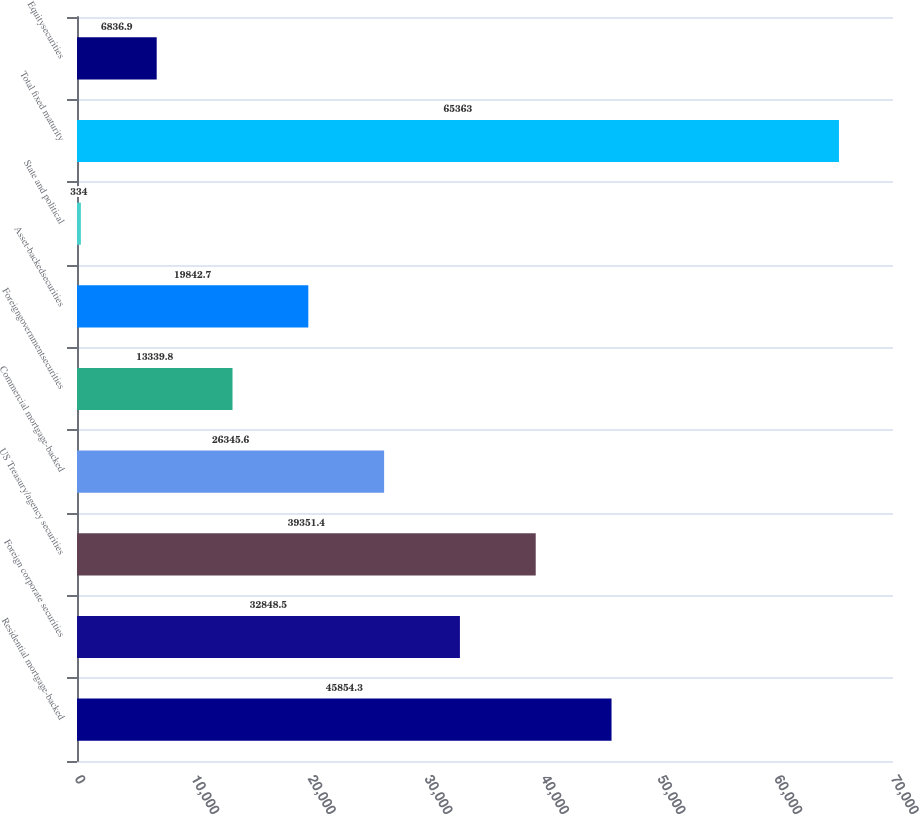Convert chart. <chart><loc_0><loc_0><loc_500><loc_500><bar_chart><fcel>Residential mortgage-backed<fcel>Foreign corporate securities<fcel>US Treasury/agency securities<fcel>Commercial mortgage-backed<fcel>Foreigngovernmentsecurities<fcel>Asset-backedsecurities<fcel>State and political<fcel>Total fixed maturity<fcel>Equitysecurities<nl><fcel>45854.3<fcel>32848.5<fcel>39351.4<fcel>26345.6<fcel>13339.8<fcel>19842.7<fcel>334<fcel>65363<fcel>6836.9<nl></chart> 